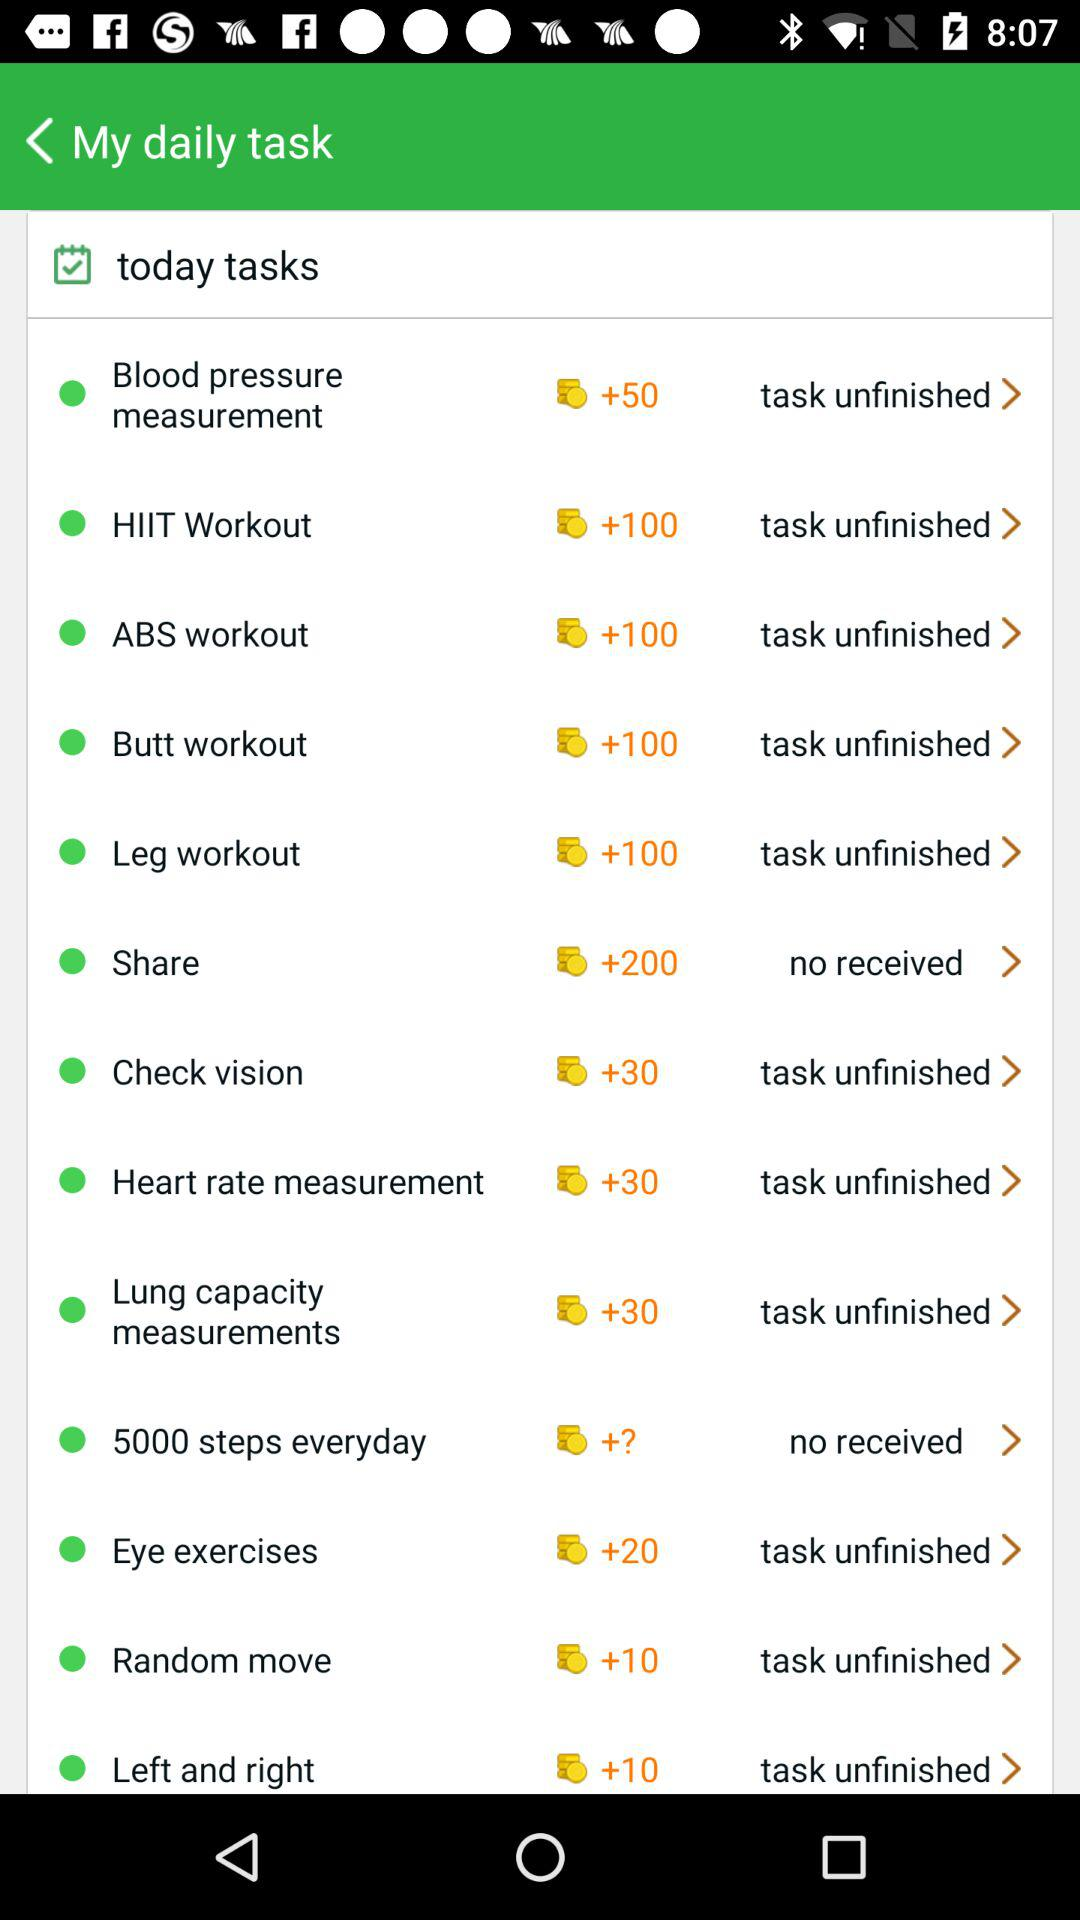Which task is not received? The tasks that are not received are "Share" and "5000 steps everyday". 